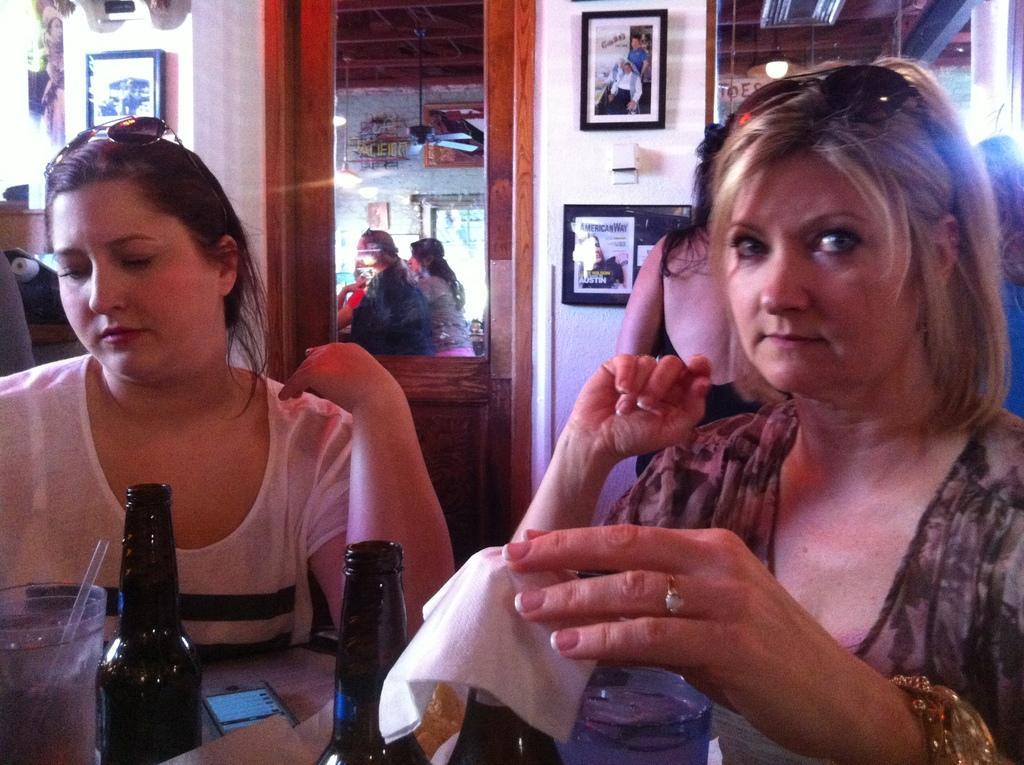Please provide a concise description of this image. As we can see in the image there is a white color wall, frames, a mirror and two people sitting in the front and a table. On table there is a mobile phone, bottles and a glass. 